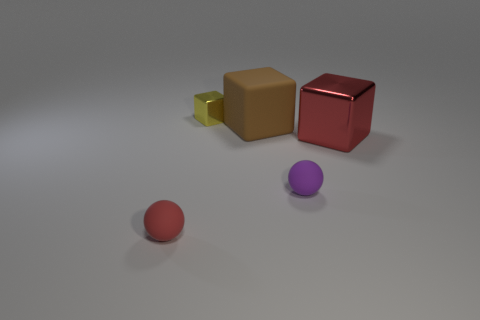How many red rubber balls have the same size as the yellow thing?
Provide a succinct answer. 1. What is the material of the brown thing?
Provide a succinct answer. Rubber. There is a metallic block on the left side of the big red shiny object; what is its size?
Give a very brief answer. Small. What number of large rubber objects are the same shape as the big shiny object?
Your answer should be compact. 1. There is a thing that is made of the same material as the red cube; what shape is it?
Keep it short and to the point. Cube. What number of red things are tiny metallic objects or shiny things?
Make the answer very short. 1. There is a yellow object; are there any things to the left of it?
Provide a short and direct response. Yes. Do the matte object that is in front of the purple object and the small object that is behind the tiny purple rubber thing have the same shape?
Provide a short and direct response. No. What is the material of the big red object that is the same shape as the small yellow object?
Keep it short and to the point. Metal. What number of blocks are green metal things or purple rubber objects?
Give a very brief answer. 0. 